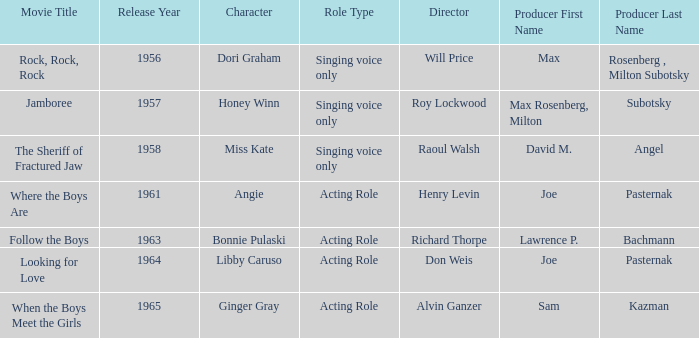Who were the producers in 1961? Joe Pasternak. 